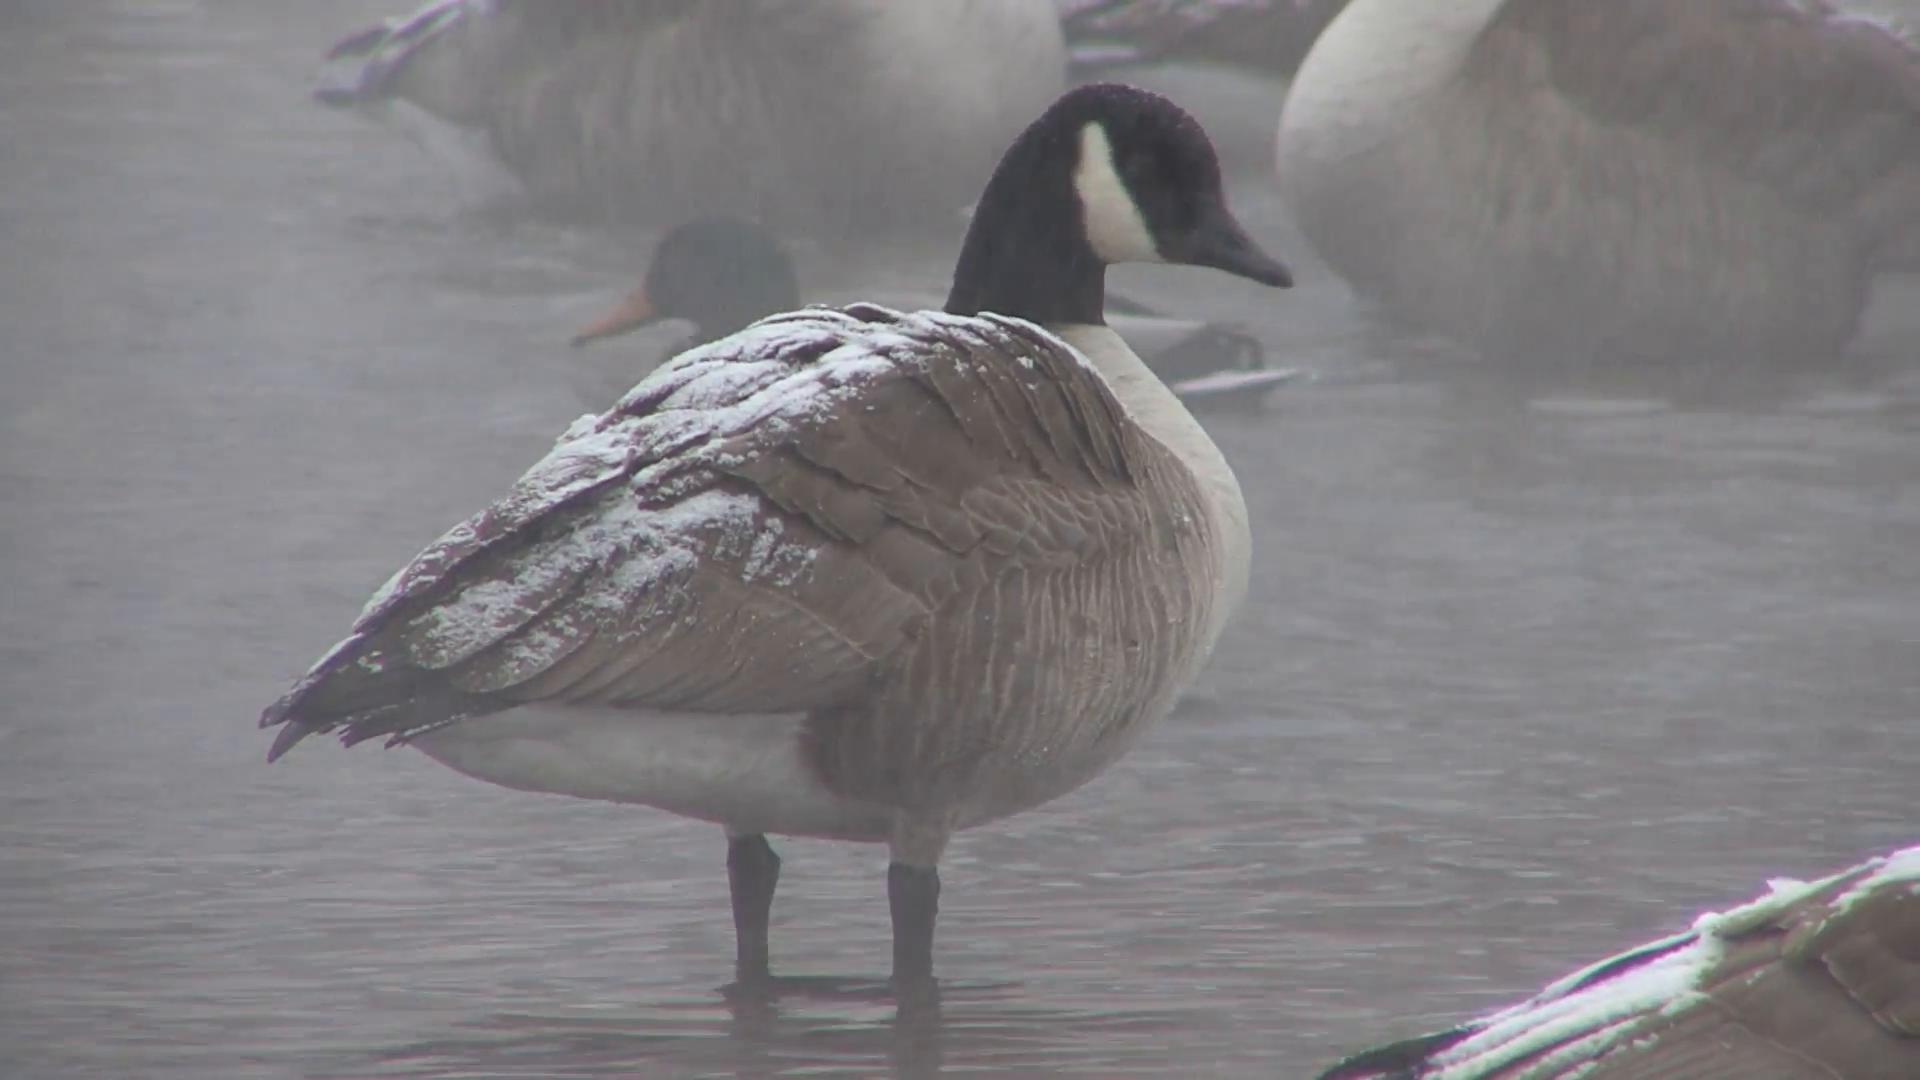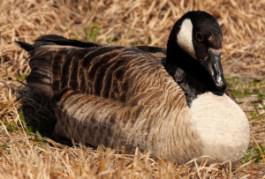The first image is the image on the left, the second image is the image on the right. Analyze the images presented: Is the assertion "There is a single geese in the foreground in each image." valid? Answer yes or no. Yes. The first image is the image on the left, the second image is the image on the right. For the images displayed, is the sentence "The bird in the image on the right is sitting in the grass." factually correct? Answer yes or no. Yes. 